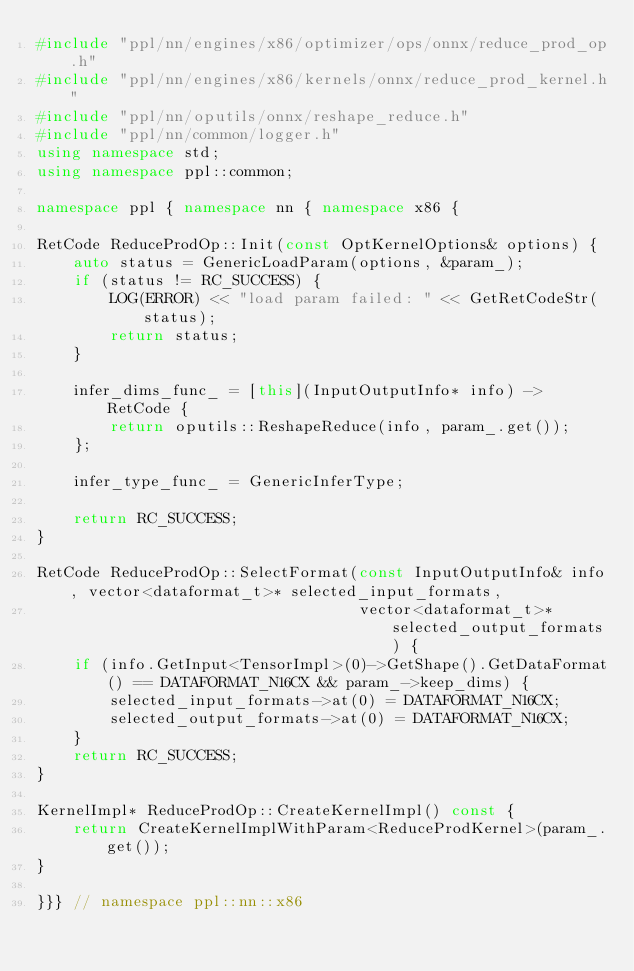<code> <loc_0><loc_0><loc_500><loc_500><_C++_>#include "ppl/nn/engines/x86/optimizer/ops/onnx/reduce_prod_op.h"
#include "ppl/nn/engines/x86/kernels/onnx/reduce_prod_kernel.h"
#include "ppl/nn/oputils/onnx/reshape_reduce.h"
#include "ppl/nn/common/logger.h"
using namespace std;
using namespace ppl::common;

namespace ppl { namespace nn { namespace x86 {

RetCode ReduceProdOp::Init(const OptKernelOptions& options) {
    auto status = GenericLoadParam(options, &param_);
    if (status != RC_SUCCESS) {
        LOG(ERROR) << "load param failed: " << GetRetCodeStr(status);
        return status;
    }

    infer_dims_func_ = [this](InputOutputInfo* info) -> RetCode {
        return oputils::ReshapeReduce(info, param_.get());
    };

    infer_type_func_ = GenericInferType;

    return RC_SUCCESS;
}

RetCode ReduceProdOp::SelectFormat(const InputOutputInfo& info, vector<dataformat_t>* selected_input_formats,
                                   vector<dataformat_t>* selected_output_formats) {
    if (info.GetInput<TensorImpl>(0)->GetShape().GetDataFormat() == DATAFORMAT_N16CX && param_->keep_dims) {
        selected_input_formats->at(0) = DATAFORMAT_N16CX;
        selected_output_formats->at(0) = DATAFORMAT_N16CX;
    }
    return RC_SUCCESS;
}

KernelImpl* ReduceProdOp::CreateKernelImpl() const {
    return CreateKernelImplWithParam<ReduceProdKernel>(param_.get());
}

}}} // namespace ppl::nn::x86
</code> 